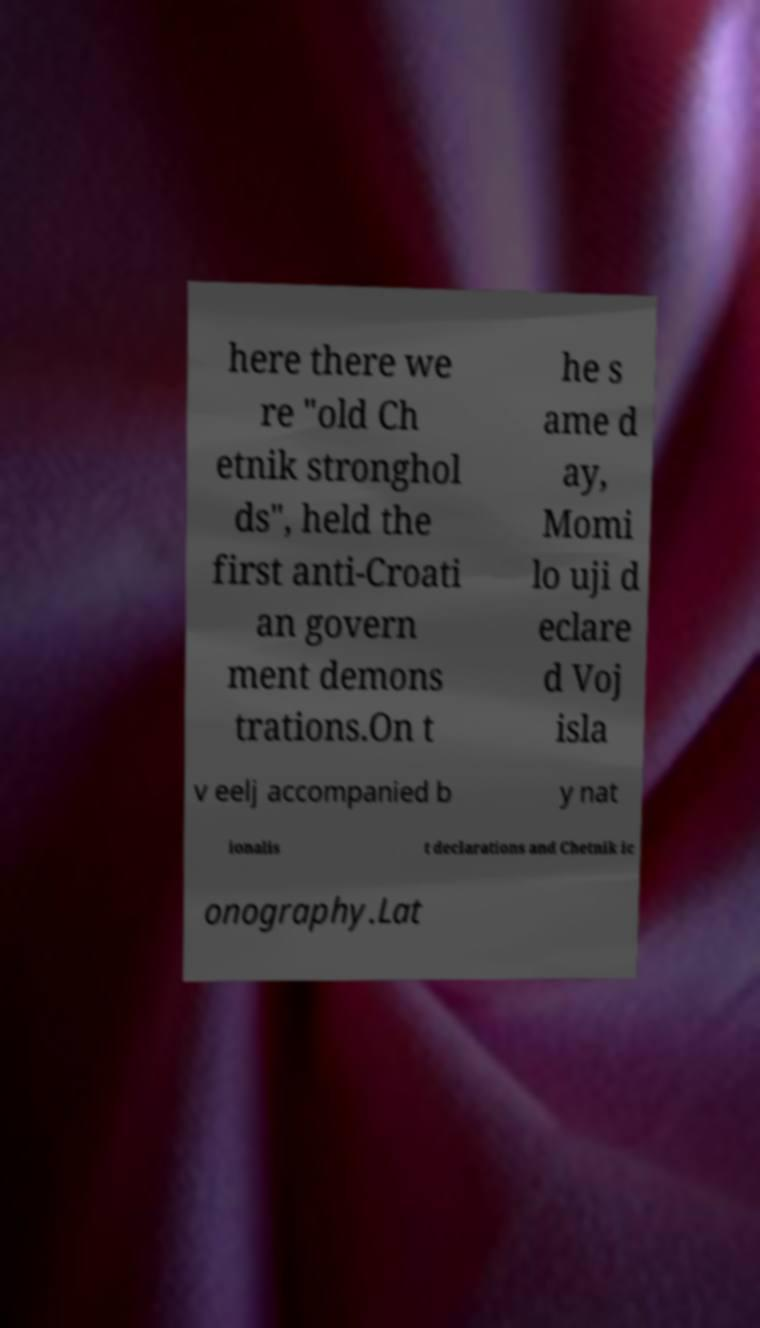Can you accurately transcribe the text from the provided image for me? here there we re "old Ch etnik stronghol ds", held the first anti-Croati an govern ment demons trations.On t he s ame d ay, Momi lo uji d eclare d Voj isla v eelj accompanied b y nat ionalis t declarations and Chetnik ic onography.Lat 